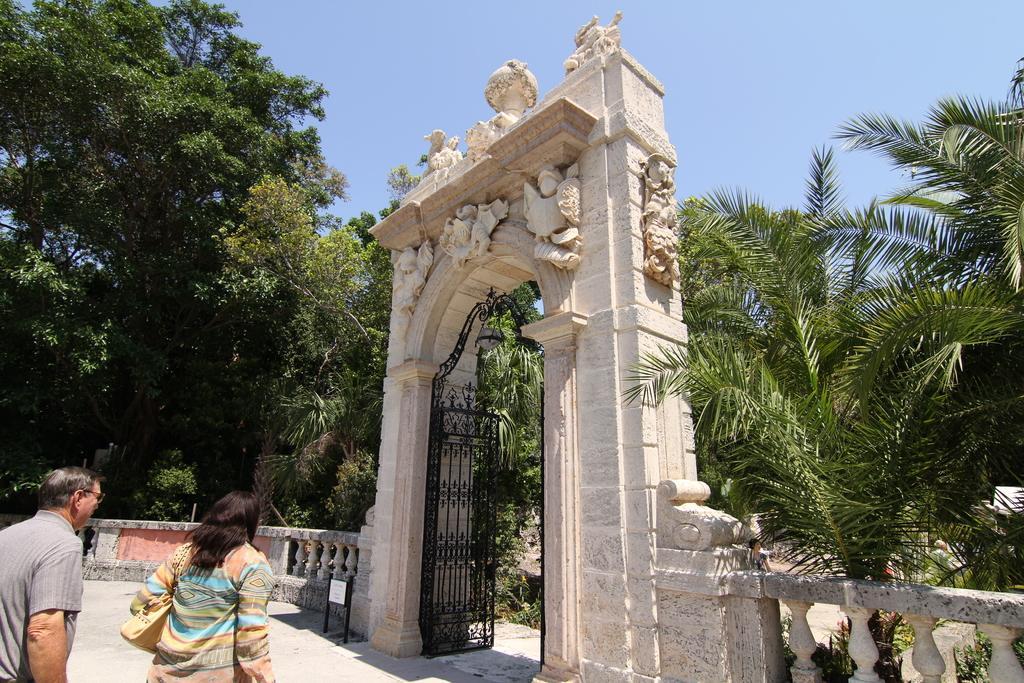Can you describe this image briefly? In this picture we can see two people on the ground were a woman carrying a bag, name board, arch with sculptures, gate, fence, trees and in the background we can see the sky. 